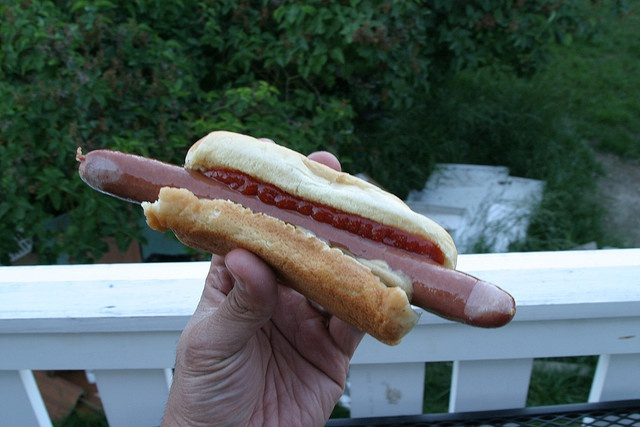Describe the objects in this image and their specific colors. I can see hot dog in darkgreen, maroon, darkgray, lightgray, and gray tones and people in darkgreen, gray, and black tones in this image. 